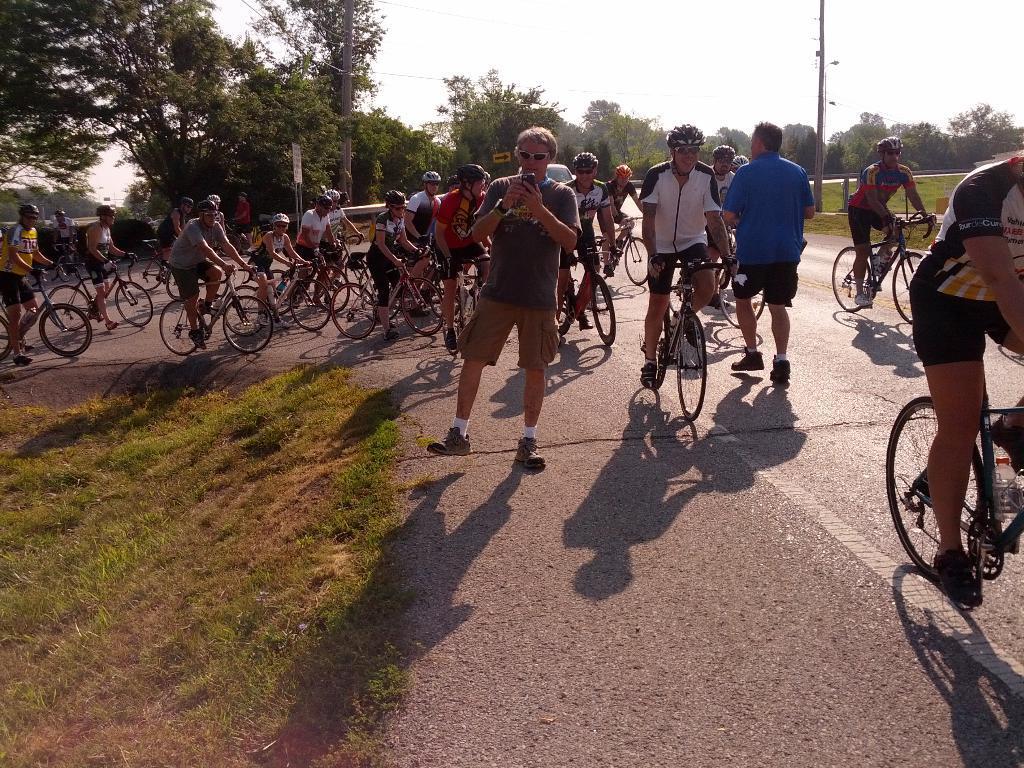Describe this image in one or two sentences. Group of people sitting and riding bicycle on the road and wear helmet,this person running and this person standing and holding mobile. On the background we can see trees,sky,pole. This is grass. 